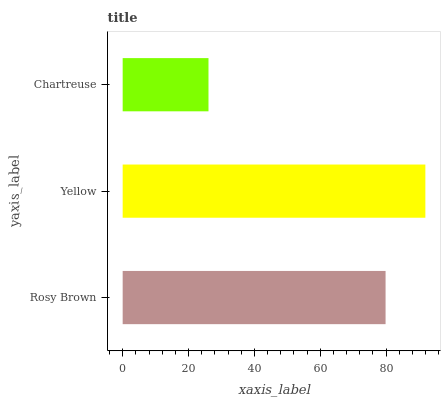Is Chartreuse the minimum?
Answer yes or no. Yes. Is Yellow the maximum?
Answer yes or no. Yes. Is Yellow the minimum?
Answer yes or no. No. Is Chartreuse the maximum?
Answer yes or no. No. Is Yellow greater than Chartreuse?
Answer yes or no. Yes. Is Chartreuse less than Yellow?
Answer yes or no. Yes. Is Chartreuse greater than Yellow?
Answer yes or no. No. Is Yellow less than Chartreuse?
Answer yes or no. No. Is Rosy Brown the high median?
Answer yes or no. Yes. Is Rosy Brown the low median?
Answer yes or no. Yes. Is Chartreuse the high median?
Answer yes or no. No. Is Yellow the low median?
Answer yes or no. No. 